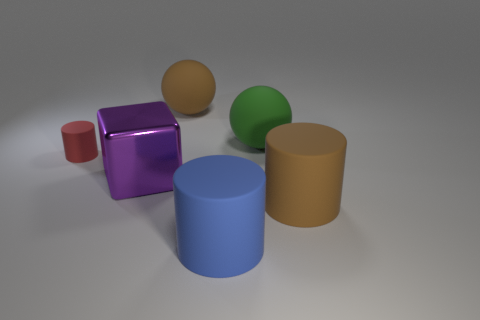Are there any other things that have the same size as the red cylinder?
Your answer should be very brief. No. There is a green ball that is the same size as the purple object; what is its material?
Your response must be concise. Rubber. Is the purple block made of the same material as the large blue object?
Provide a succinct answer. No. How many large purple cubes are made of the same material as the blue object?
Keep it short and to the point. 0. How many objects are either cylinders that are in front of the tiny red rubber object or brown matte objects right of the big metallic cube?
Provide a short and direct response. 3. Are there more blue objects that are behind the large block than big brown rubber objects that are to the right of the small object?
Your answer should be very brief. No. What color is the cylinder that is behind the big purple shiny object?
Your answer should be compact. Red. Are there any tiny objects that have the same shape as the large purple thing?
Offer a very short reply. No. What number of gray objects are either tiny things or big matte things?
Keep it short and to the point. 0. Is there a green sphere of the same size as the purple thing?
Offer a terse response. Yes. 